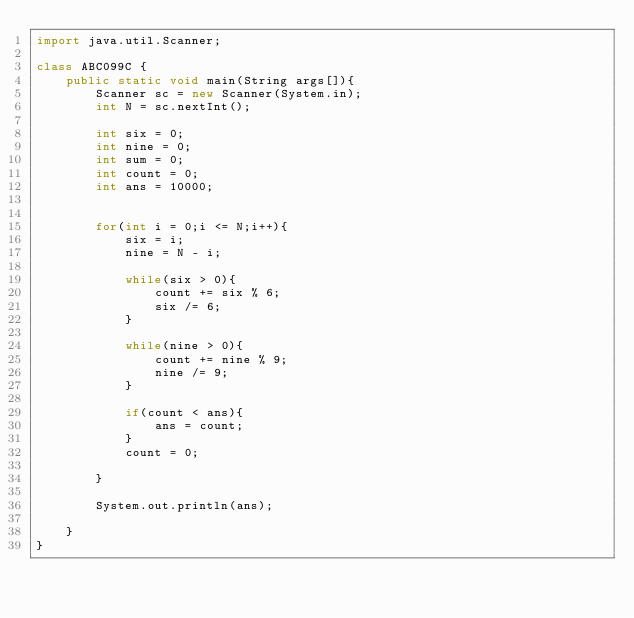Convert code to text. <code><loc_0><loc_0><loc_500><loc_500><_Java_>import java.util.Scanner;

class ABC099C {
	public static void main(String args[]){
		Scanner sc = new Scanner(System.in);
		int N = sc.nextInt();

		int six = 0;
		int nine = 0;
		int sum = 0;
		int count = 0;
		int ans = 10000;

		
		for(int i = 0;i <= N;i++){
			six = i;
			nine = N - i;

			while(six > 0){
				count += six % 6;
				six /= 6;
			}

			while(nine > 0){
				count += nine % 9;
				nine /= 9;
			}

			if(count < ans){
				ans = count;
			}
			count = 0;

		}

		System.out.println(ans);

	}
}

</code> 